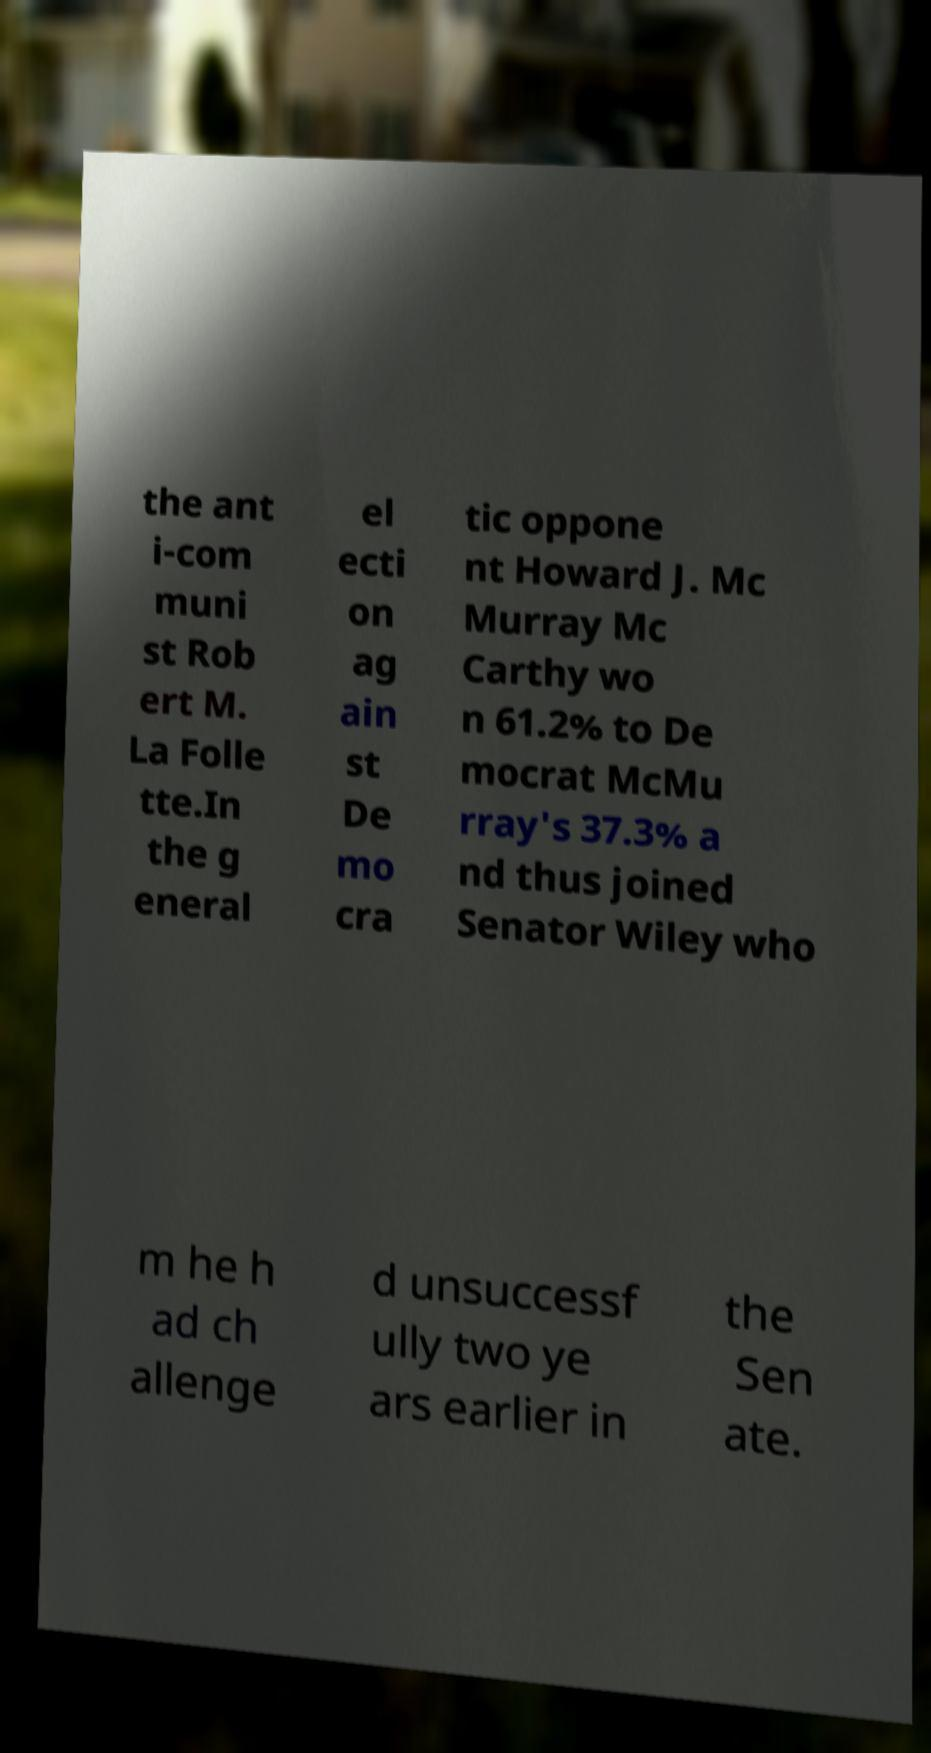Can you read and provide the text displayed in the image?This photo seems to have some interesting text. Can you extract and type it out for me? the ant i-com muni st Rob ert M. La Folle tte.In the g eneral el ecti on ag ain st De mo cra tic oppone nt Howard J. Mc Murray Mc Carthy wo n 61.2% to De mocrat McMu rray's 37.3% a nd thus joined Senator Wiley who m he h ad ch allenge d unsuccessf ully two ye ars earlier in the Sen ate. 